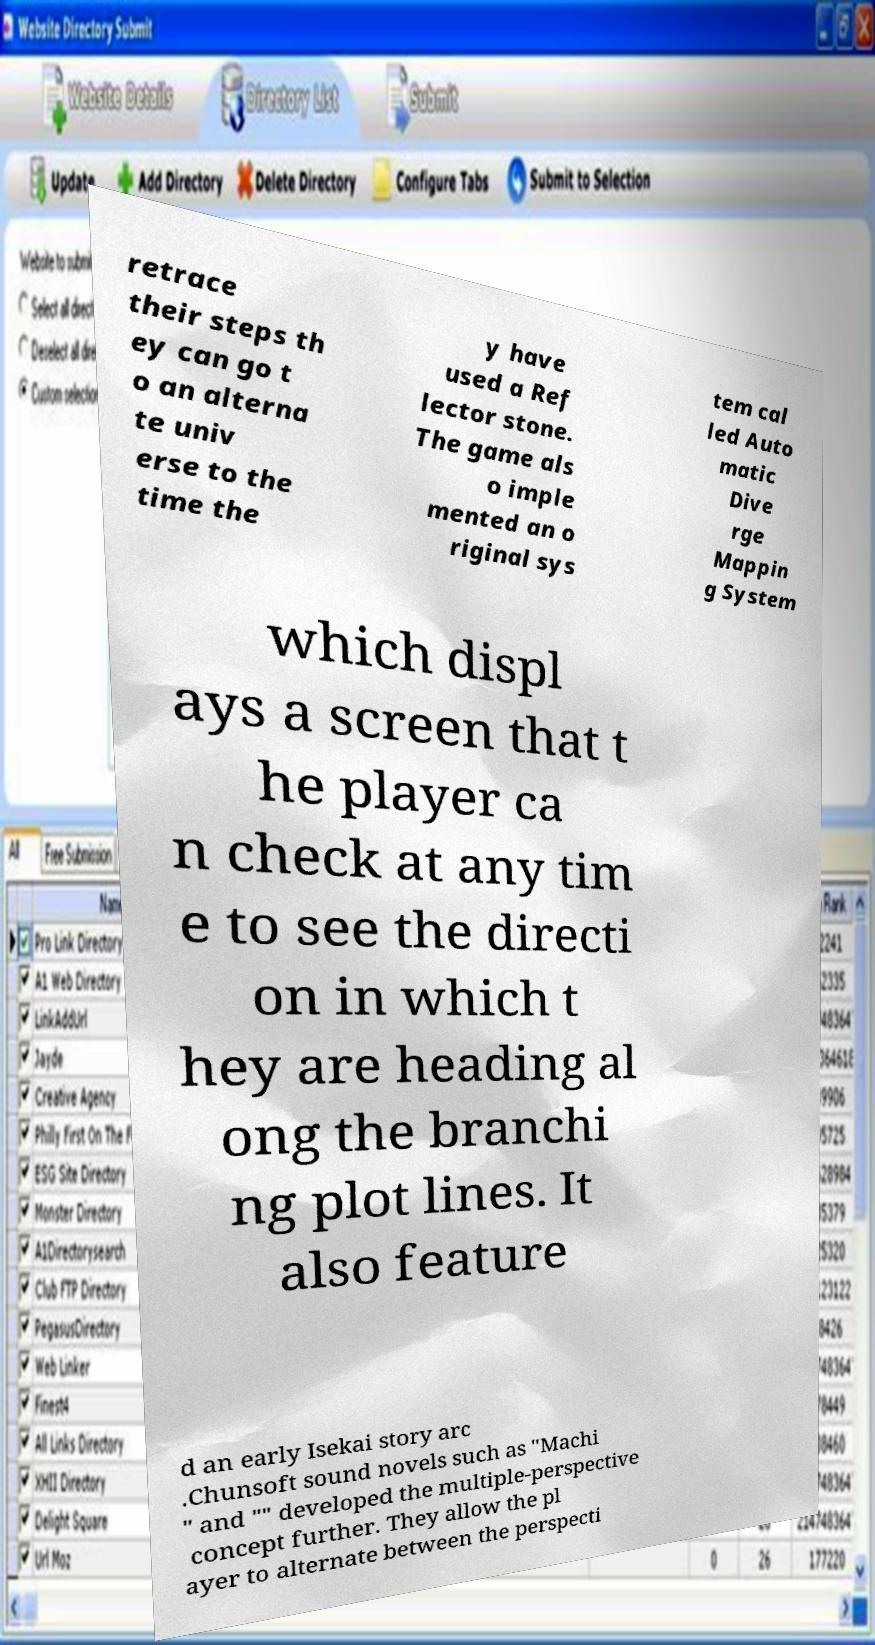Please identify and transcribe the text found in this image. retrace their steps th ey can go t o an alterna te univ erse to the time the y have used a Ref lector stone. The game als o imple mented an o riginal sys tem cal led Auto matic Dive rge Mappin g System which displ ays a screen that t he player ca n check at any tim e to see the directi on in which t hey are heading al ong the branchi ng plot lines. It also feature d an early Isekai story arc .Chunsoft sound novels such as "Machi " and "" developed the multiple-perspective concept further. They allow the pl ayer to alternate between the perspecti 